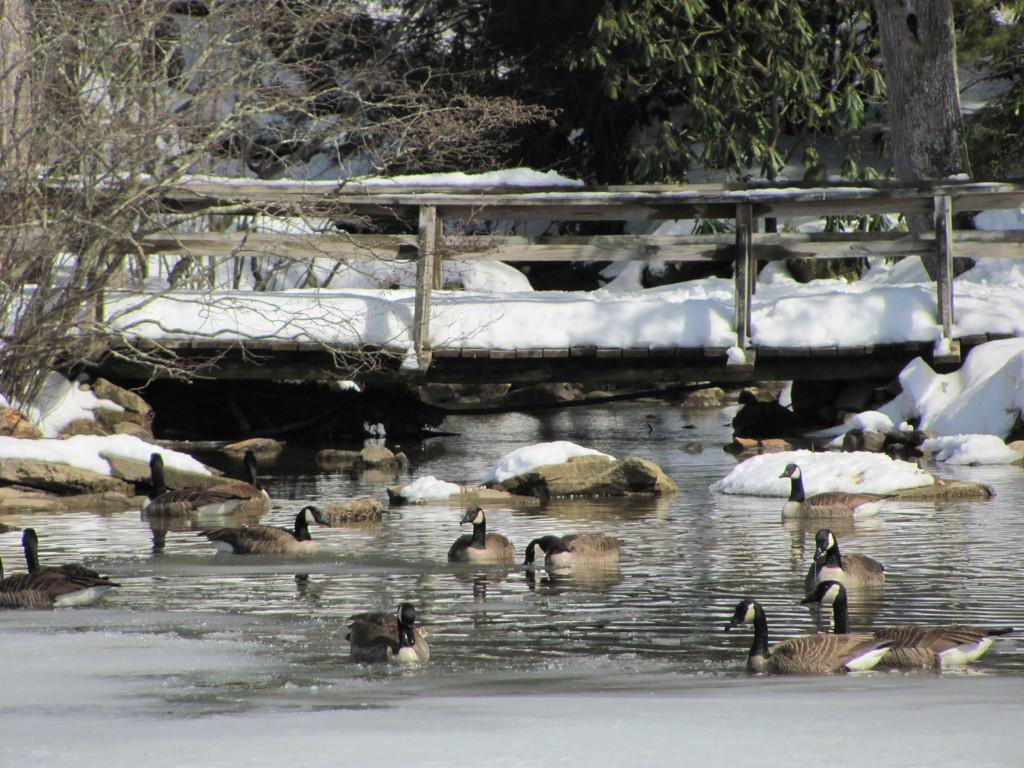What type of animals can be seen in the image? There are ducks in the water in the image. What natural elements are visible in the image? There are rocks and trees visible in the image. What type of structure is present in the image? There is a wooden bridge in the image. How is the wooden bridge affected by the weather? The wooden bridge is partially covered with snow. What type of fruit is the duck holding in the image? There is no fruit present in the image, and the ducks are not holding anything. 